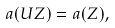Convert formula to latex. <formula><loc_0><loc_0><loc_500><loc_500>a ( U Z ) = a ( Z ) ,</formula> 